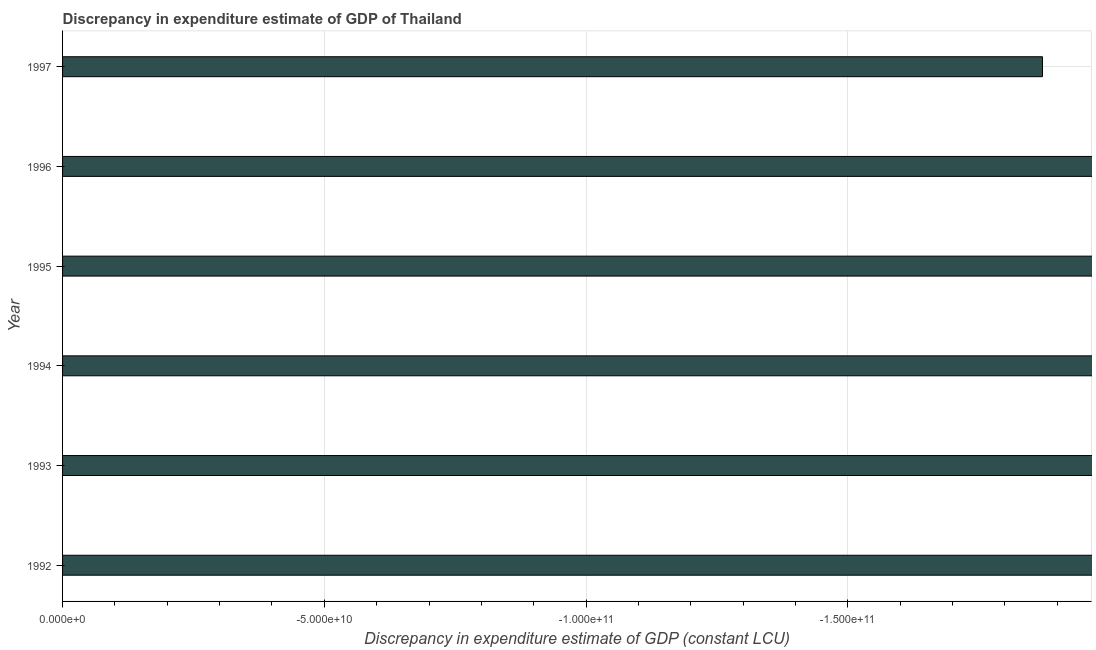Does the graph contain any zero values?
Give a very brief answer. Yes. What is the title of the graph?
Provide a short and direct response. Discrepancy in expenditure estimate of GDP of Thailand. What is the label or title of the X-axis?
Keep it short and to the point. Discrepancy in expenditure estimate of GDP (constant LCU). What is the label or title of the Y-axis?
Your answer should be compact. Year. What is the average discrepancy in expenditure estimate of gdp per year?
Your response must be concise. 0. What is the median discrepancy in expenditure estimate of gdp?
Give a very brief answer. 0. What is the difference between two consecutive major ticks on the X-axis?
Offer a terse response. 5.00e+1. Are the values on the major ticks of X-axis written in scientific E-notation?
Keep it short and to the point. Yes. What is the Discrepancy in expenditure estimate of GDP (constant LCU) in 1994?
Make the answer very short. 0. 